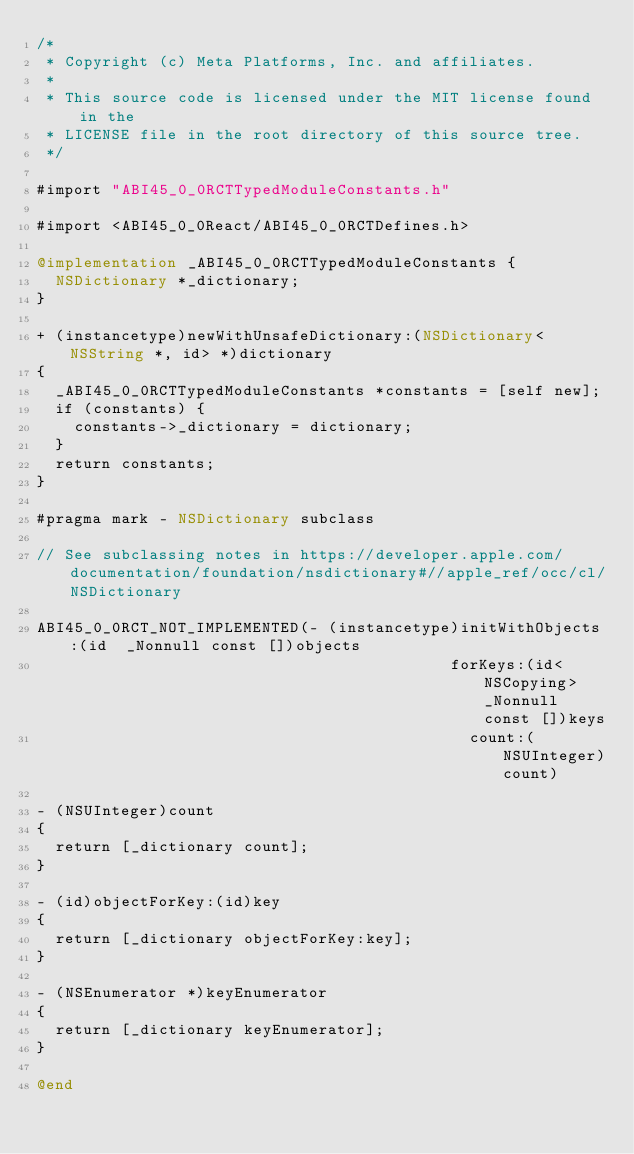Convert code to text. <code><loc_0><loc_0><loc_500><loc_500><_ObjectiveC_>/*
 * Copyright (c) Meta Platforms, Inc. and affiliates.
 *
 * This source code is licensed under the MIT license found in the
 * LICENSE file in the root directory of this source tree.
 */

#import "ABI45_0_0RCTTypedModuleConstants.h"

#import <ABI45_0_0React/ABI45_0_0RCTDefines.h>

@implementation _ABI45_0_0RCTTypedModuleConstants {
  NSDictionary *_dictionary;
}

+ (instancetype)newWithUnsafeDictionary:(NSDictionary<NSString *, id> *)dictionary
{
  _ABI45_0_0RCTTypedModuleConstants *constants = [self new];
  if (constants) {
    constants->_dictionary = dictionary;
  }
  return constants;
}

#pragma mark - NSDictionary subclass

// See subclassing notes in https://developer.apple.com/documentation/foundation/nsdictionary#//apple_ref/occ/cl/NSDictionary

ABI45_0_0RCT_NOT_IMPLEMENTED(- (instancetype)initWithObjects:(id  _Nonnull const [])objects
                                            forKeys:(id<NSCopying> _Nonnull const [])keys
                                              count:(NSUInteger)count)

- (NSUInteger)count
{
  return [_dictionary count];
}

- (id)objectForKey:(id)key
{
  return [_dictionary objectForKey:key];
}

- (NSEnumerator *)keyEnumerator
{
  return [_dictionary keyEnumerator];
}

@end
</code> 